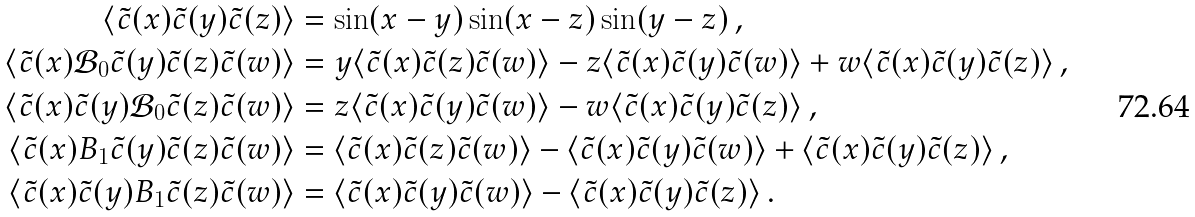Convert formula to latex. <formula><loc_0><loc_0><loc_500><loc_500>\langle \tilde { c } ( x ) \tilde { c } ( y ) \tilde { c } ( z ) \rangle & = \sin ( x - y ) \sin ( x - z ) \sin ( y - z ) \, , \\ \langle \tilde { c } ( x ) \mathcal { B } _ { 0 } \tilde { c } ( y ) \tilde { c } ( z ) \tilde { c } ( w ) \rangle & = y \langle \tilde { c } ( x ) \tilde { c } ( z ) \tilde { c } ( w ) \rangle - z \langle \tilde { c } ( x ) \tilde { c } ( y ) \tilde { c } ( w ) \rangle + w \langle \tilde { c } ( x ) \tilde { c } ( y ) \tilde { c } ( z ) \rangle \, , \\ \langle \tilde { c } ( x ) \tilde { c } ( y ) \mathcal { B } _ { 0 } \tilde { c } ( z ) \tilde { c } ( w ) \rangle & = z \langle \tilde { c } ( x ) \tilde { c } ( y ) \tilde { c } ( w ) \rangle - w \langle \tilde { c } ( x ) \tilde { c } ( y ) \tilde { c } ( z ) \rangle \, , \\ \langle \tilde { c } ( x ) B _ { 1 } \tilde { c } ( y ) \tilde { c } ( z ) \tilde { c } ( w ) \rangle & = \langle \tilde { c } ( x ) \tilde { c } ( z ) \tilde { c } ( w ) \rangle - \langle \tilde { c } ( x ) \tilde { c } ( y ) \tilde { c } ( w ) \rangle + \langle \tilde { c } ( x ) \tilde { c } ( y ) \tilde { c } ( z ) \rangle \, , \\ \langle \tilde { c } ( x ) \tilde { c } ( y ) B _ { 1 } \tilde { c } ( z ) \tilde { c } ( w ) \rangle & = \langle \tilde { c } ( x ) \tilde { c } ( y ) \tilde { c } ( w ) \rangle - \langle \tilde { c } ( x ) \tilde { c } ( y ) \tilde { c } ( z ) \rangle \, .</formula> 